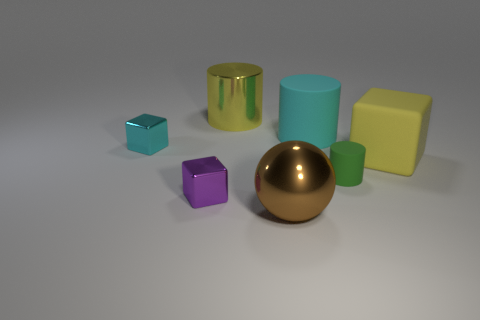There is a big cylinder that is made of the same material as the large yellow block; what color is it? The large cylinder appears to share the same matte surface finish as the large yellow block, indicating that they are made of a similar material. However, the cylinder is not yellow; it is actually a sky blue color. 